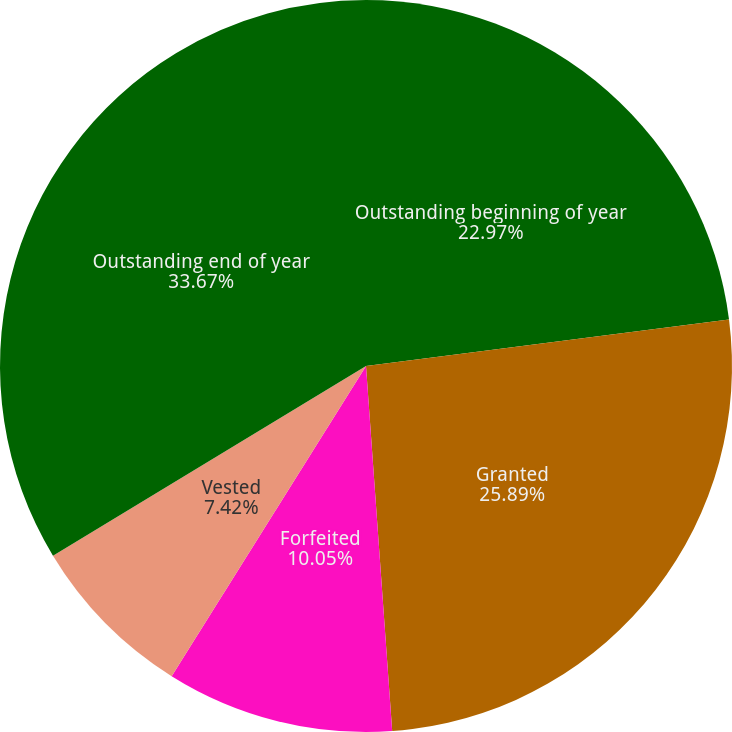Convert chart. <chart><loc_0><loc_0><loc_500><loc_500><pie_chart><fcel>Outstanding beginning of year<fcel>Granted<fcel>Forfeited<fcel>Vested<fcel>Outstanding end of year<nl><fcel>22.97%<fcel>25.89%<fcel>10.05%<fcel>7.42%<fcel>33.67%<nl></chart> 